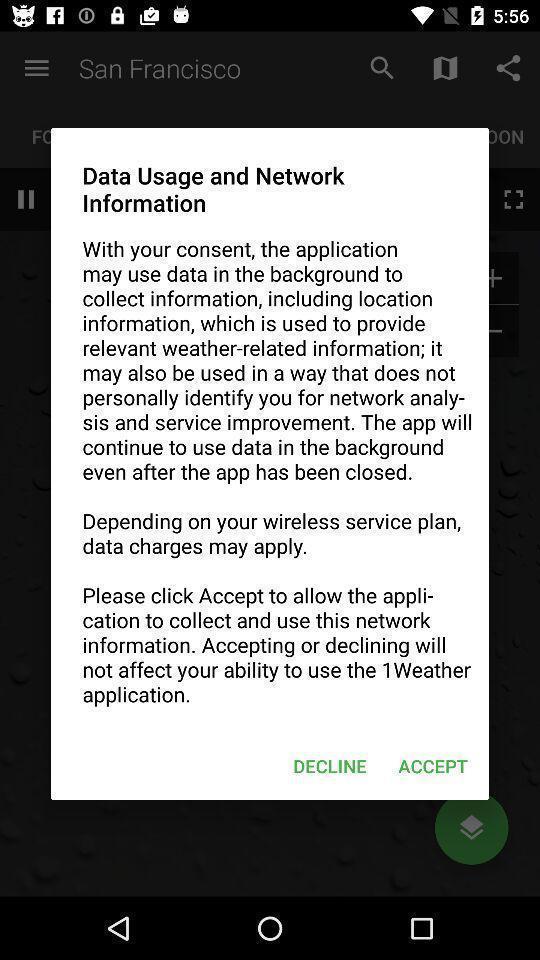What is the overall content of this screenshot? Pop-up shows message about data usage and network information. 